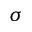<formula> <loc_0><loc_0><loc_500><loc_500>\sigma</formula> 